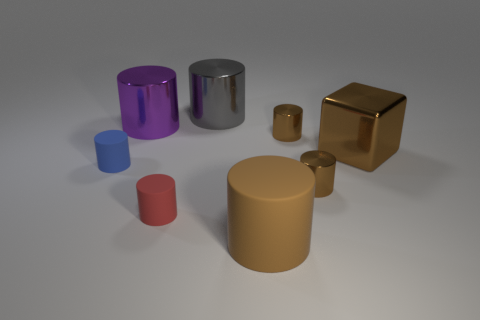What size is the metallic cylinder that is in front of the big metal cube?
Ensure brevity in your answer.  Small. There is a big shiny cylinder that is to the left of the gray metal object; does it have the same color as the big metal cube behind the small blue thing?
Offer a terse response. No. What material is the large thing to the left of the metal object behind the large thing that is on the left side of the small red cylinder?
Offer a terse response. Metal. Are there any other metallic blocks of the same size as the brown metal block?
Your answer should be compact. No. There is a brown thing that is the same size as the brown metal block; what is it made of?
Keep it short and to the point. Rubber. There is a metal object on the left side of the gray thing; what is its shape?
Offer a terse response. Cylinder. Does the big cylinder in front of the purple object have the same material as the large object that is right of the big rubber cylinder?
Make the answer very short. No. What number of brown objects are the same shape as the small blue matte thing?
Give a very brief answer. 3. What material is the large thing that is the same color as the shiny block?
Offer a very short reply. Rubber. How many objects are large brown things or small brown things in front of the blue object?
Offer a very short reply. 3. 